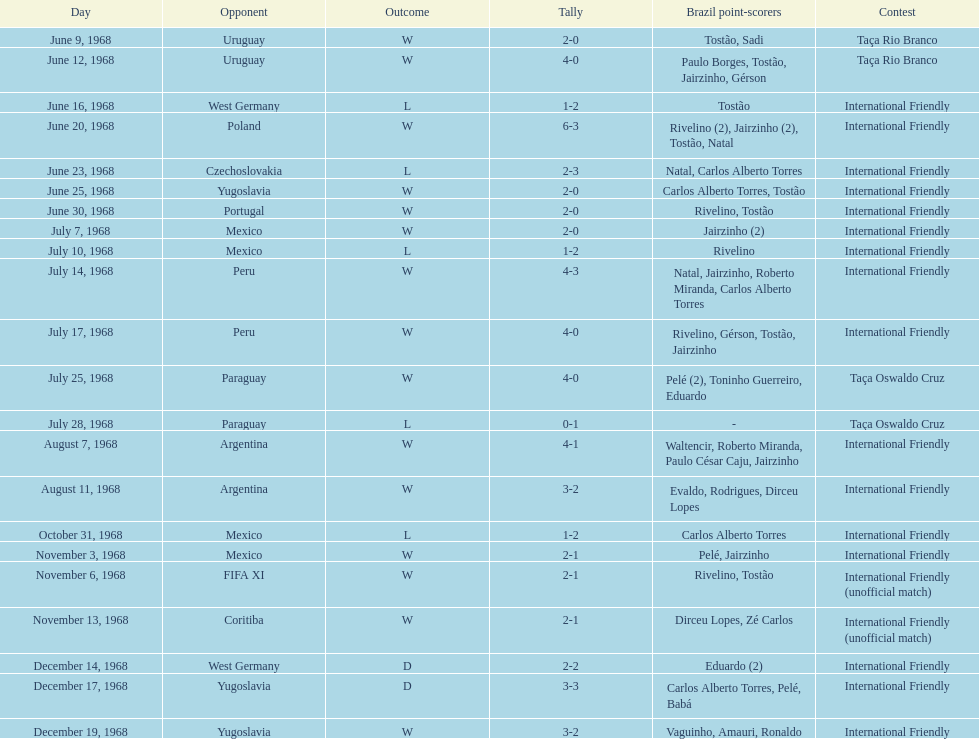What year has the highest scoring game? 1968. 